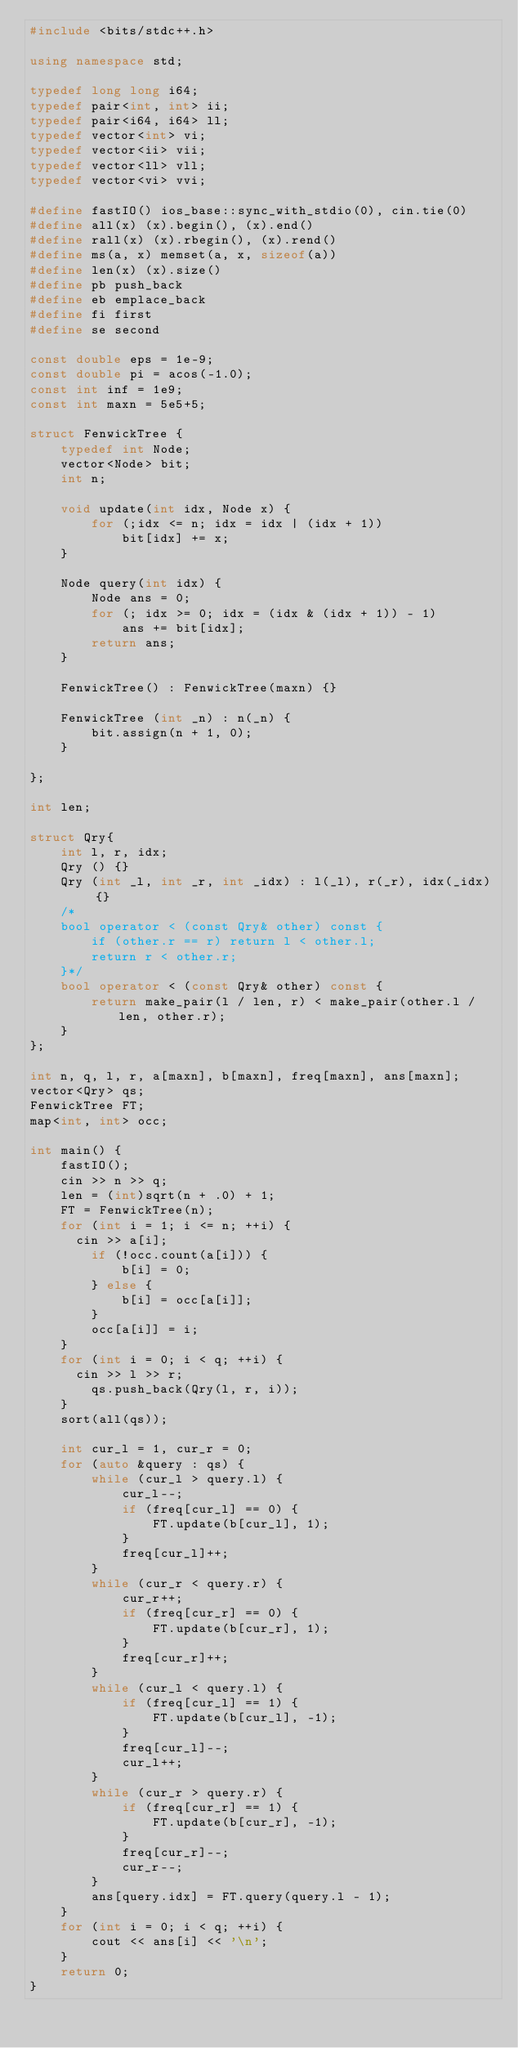Convert code to text. <code><loc_0><loc_0><loc_500><loc_500><_C++_>#include <bits/stdc++.h>

using namespace std;

typedef long long i64;
typedef pair<int, int> ii;
typedef pair<i64, i64> ll;
typedef vector<int> vi;
typedef vector<ii> vii;
typedef vector<ll> vll;
typedef vector<vi> vvi;

#define fastIO() ios_base::sync_with_stdio(0), cin.tie(0)
#define all(x) (x).begin(), (x).end()
#define rall(x) (x).rbegin(), (x).rend()
#define ms(a, x) memset(a, x, sizeof(a))
#define len(x) (x).size()
#define pb push_back
#define eb emplace_back
#define fi first
#define se second

const double eps = 1e-9;
const double pi = acos(-1.0);
const int inf = 1e9;
const int maxn = 5e5+5;

struct FenwickTree {
    typedef int Node;
    vector<Node> bit;
    int n;

    void update(int idx, Node x) {
        for (;idx <= n; idx = idx | (idx + 1))
            bit[idx] += x;
    }

    Node query(int idx) {
        Node ans = 0;
        for (; idx >= 0; idx = (idx & (idx + 1)) - 1)
            ans += bit[idx];
        return ans;
    }

    FenwickTree() : FenwickTree(maxn) {}

    FenwickTree (int _n) : n(_n) {
        bit.assign(n + 1, 0);
    }
 
};

int len;

struct Qry{
    int l, r, idx;
    Qry () {}
    Qry (int _l, int _r, int _idx) : l(_l), r(_r), idx(_idx) {}
    /*
    bool operator < (const Qry& other) const {
        if (other.r == r) return l < other.l;
        return r < other.r;
    }*/
    bool operator < (const Qry& other) const {
        return make_pair(l / len, r) < make_pair(other.l / len, other.r);
    }
};

int n, q, l, r, a[maxn], b[maxn], freq[maxn], ans[maxn];
vector<Qry> qs;
FenwickTree FT;
map<int, int> occ;

int main() {
    fastIO();
    cin >> n >> q;
    len = (int)sqrt(n + .0) + 1;
    FT = FenwickTree(n);
    for (int i = 1; i <= n; ++i) {
    	cin >> a[i];
        if (!occ.count(a[i])) {
            b[i] = 0;
        } else {
            b[i] = occ[a[i]];
        }
        occ[a[i]] = i;
    }
    for (int i = 0; i < q; ++i) {
    	cin >> l >> r;
        qs.push_back(Qry(l, r, i));
    }
    sort(all(qs));

    int cur_l = 1, cur_r = 0;
    for (auto &query : qs) {
        while (cur_l > query.l) {
            cur_l--;
            if (freq[cur_l] == 0) {
                FT.update(b[cur_l], 1);
            }
            freq[cur_l]++;
        }
        while (cur_r < query.r) {
            cur_r++;
            if (freq[cur_r] == 0) {
                FT.update(b[cur_r], 1);
            }
            freq[cur_r]++;
        }
        while (cur_l < query.l) {
            if (freq[cur_l] == 1) {
                FT.update(b[cur_l], -1);
            }
            freq[cur_l]--;
            cur_l++;
        }
        while (cur_r > query.r) {
            if (freq[cur_r] == 1) {
                FT.update(b[cur_r], -1);
            }
            freq[cur_r]--;
            cur_r--;
        }
        ans[query.idx] = FT.query(query.l - 1);
    }
    for (int i = 0; i < q; ++i) {
        cout << ans[i] << '\n';
    }
    return 0;
}
</code> 